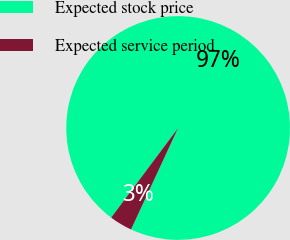<chart> <loc_0><loc_0><loc_500><loc_500><pie_chart><fcel>Expected stock price<fcel>Expected service period<nl><fcel>96.7%<fcel>3.3%<nl></chart> 